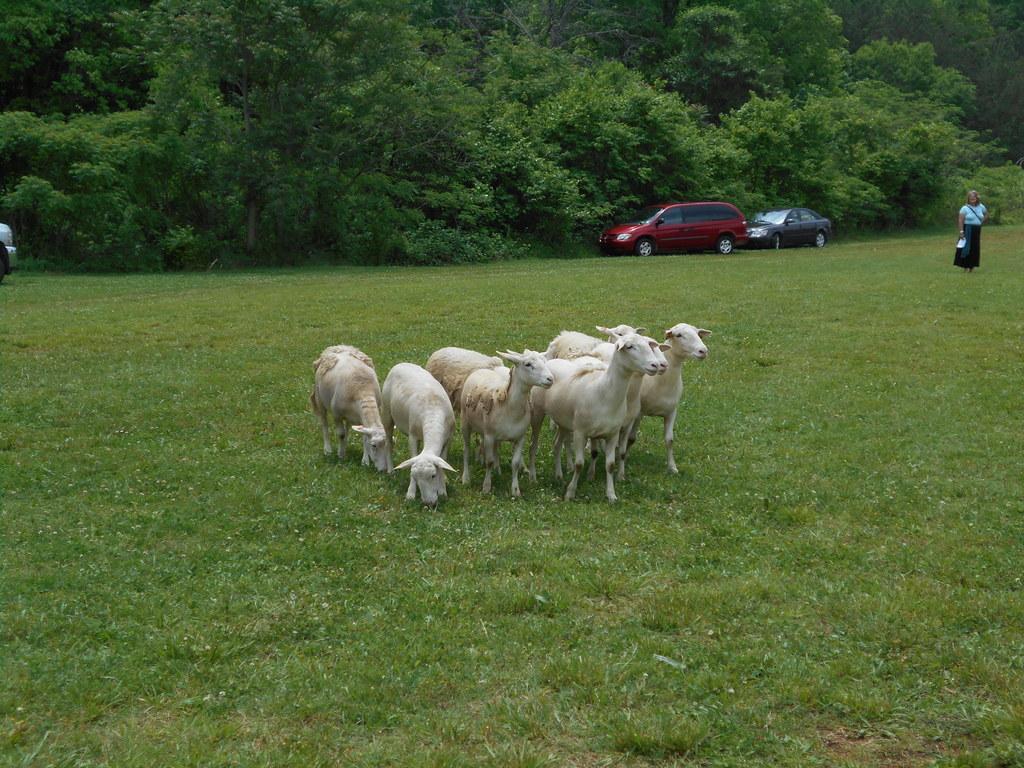Please provide a concise description of this image. In the picture I can see white color goats standing on the ground. In the background I can see vehicles, a person standing on the ground, trees, the grass and some other objects. 